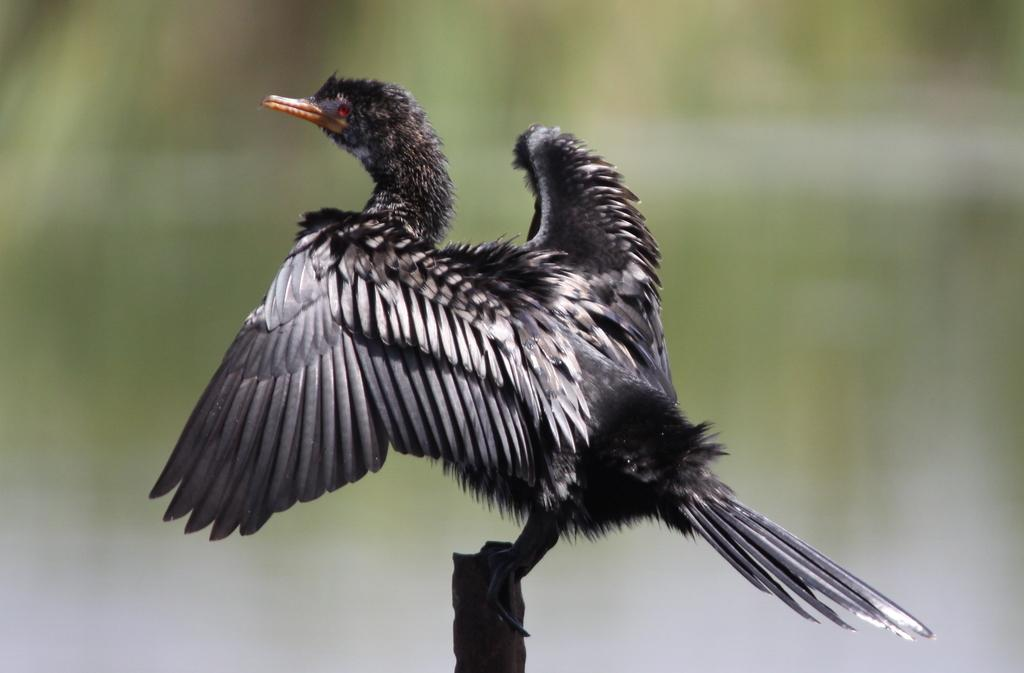What type of animal is present in the image? There is a bird in the image. What color is the bird? The bird is black in color. What is the color of the bird's beak? The bird has an orange beak. What can be seen in the background of the image? The background of the image is green and blurred. What type of cloth is the bird using to cover its wings in the image? There is no cloth present in the image, and the bird is not using any cloth to cover its wings. 